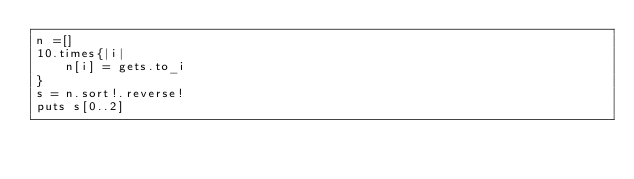<code> <loc_0><loc_0><loc_500><loc_500><_Ruby_>n =[]
10.times{|i|
    n[i] = gets.to_i
}
s = n.sort!.reverse!
puts s[0..2]
</code> 